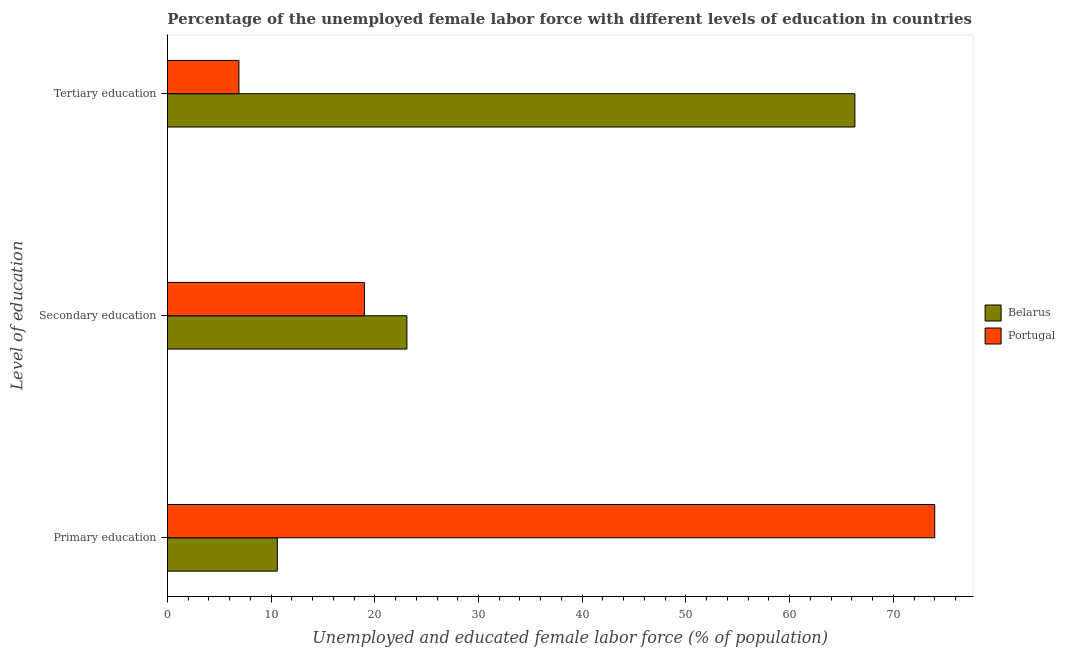How many groups of bars are there?
Offer a very short reply. 3. Are the number of bars per tick equal to the number of legend labels?
Give a very brief answer. Yes. How many bars are there on the 2nd tick from the top?
Provide a short and direct response. 2. How many bars are there on the 1st tick from the bottom?
Provide a short and direct response. 2. What is the label of the 2nd group of bars from the top?
Your response must be concise. Secondary education. What is the percentage of female labor force who received primary education in Belarus?
Your response must be concise. 10.6. Across all countries, what is the maximum percentage of female labor force who received tertiary education?
Offer a very short reply. 66.3. Across all countries, what is the minimum percentage of female labor force who received tertiary education?
Provide a succinct answer. 6.9. In which country was the percentage of female labor force who received tertiary education maximum?
Provide a short and direct response. Belarus. What is the total percentage of female labor force who received tertiary education in the graph?
Give a very brief answer. 73.2. What is the difference between the percentage of female labor force who received primary education in Portugal and that in Belarus?
Your answer should be compact. 63.4. What is the difference between the percentage of female labor force who received secondary education in Portugal and the percentage of female labor force who received tertiary education in Belarus?
Offer a very short reply. -47.3. What is the average percentage of female labor force who received primary education per country?
Your response must be concise. 42.3. What is the difference between the percentage of female labor force who received tertiary education and percentage of female labor force who received secondary education in Belarus?
Provide a short and direct response. 43.2. What is the ratio of the percentage of female labor force who received tertiary education in Portugal to that in Belarus?
Offer a very short reply. 0.1. Is the percentage of female labor force who received tertiary education in Belarus less than that in Portugal?
Give a very brief answer. No. What is the difference between the highest and the second highest percentage of female labor force who received secondary education?
Keep it short and to the point. 4.1. What is the difference between the highest and the lowest percentage of female labor force who received tertiary education?
Keep it short and to the point. 59.4. Is the sum of the percentage of female labor force who received primary education in Portugal and Belarus greater than the maximum percentage of female labor force who received secondary education across all countries?
Offer a terse response. Yes. What does the 2nd bar from the top in Primary education represents?
Your answer should be very brief. Belarus. How many countries are there in the graph?
Your answer should be compact. 2. Does the graph contain any zero values?
Offer a very short reply. No. Does the graph contain grids?
Provide a short and direct response. No. Where does the legend appear in the graph?
Provide a short and direct response. Center right. How are the legend labels stacked?
Your answer should be very brief. Vertical. What is the title of the graph?
Your response must be concise. Percentage of the unemployed female labor force with different levels of education in countries. Does "Turks and Caicos Islands" appear as one of the legend labels in the graph?
Ensure brevity in your answer.  No. What is the label or title of the X-axis?
Offer a very short reply. Unemployed and educated female labor force (% of population). What is the label or title of the Y-axis?
Offer a terse response. Level of education. What is the Unemployed and educated female labor force (% of population) in Belarus in Primary education?
Your answer should be compact. 10.6. What is the Unemployed and educated female labor force (% of population) of Portugal in Primary education?
Your answer should be compact. 74. What is the Unemployed and educated female labor force (% of population) of Belarus in Secondary education?
Provide a short and direct response. 23.1. What is the Unemployed and educated female labor force (% of population) in Portugal in Secondary education?
Make the answer very short. 19. What is the Unemployed and educated female labor force (% of population) of Belarus in Tertiary education?
Offer a very short reply. 66.3. What is the Unemployed and educated female labor force (% of population) in Portugal in Tertiary education?
Offer a terse response. 6.9. Across all Level of education, what is the maximum Unemployed and educated female labor force (% of population) in Belarus?
Ensure brevity in your answer.  66.3. Across all Level of education, what is the maximum Unemployed and educated female labor force (% of population) of Portugal?
Ensure brevity in your answer.  74. Across all Level of education, what is the minimum Unemployed and educated female labor force (% of population) of Belarus?
Your response must be concise. 10.6. Across all Level of education, what is the minimum Unemployed and educated female labor force (% of population) of Portugal?
Provide a succinct answer. 6.9. What is the total Unemployed and educated female labor force (% of population) in Belarus in the graph?
Give a very brief answer. 100. What is the total Unemployed and educated female labor force (% of population) of Portugal in the graph?
Make the answer very short. 99.9. What is the difference between the Unemployed and educated female labor force (% of population) of Belarus in Primary education and that in Tertiary education?
Your response must be concise. -55.7. What is the difference between the Unemployed and educated female labor force (% of population) of Portugal in Primary education and that in Tertiary education?
Ensure brevity in your answer.  67.1. What is the difference between the Unemployed and educated female labor force (% of population) of Belarus in Secondary education and that in Tertiary education?
Your response must be concise. -43.2. What is the difference between the Unemployed and educated female labor force (% of population) in Belarus in Primary education and the Unemployed and educated female labor force (% of population) in Portugal in Tertiary education?
Offer a terse response. 3.7. What is the difference between the Unemployed and educated female labor force (% of population) of Belarus in Secondary education and the Unemployed and educated female labor force (% of population) of Portugal in Tertiary education?
Ensure brevity in your answer.  16.2. What is the average Unemployed and educated female labor force (% of population) in Belarus per Level of education?
Ensure brevity in your answer.  33.33. What is the average Unemployed and educated female labor force (% of population) of Portugal per Level of education?
Keep it short and to the point. 33.3. What is the difference between the Unemployed and educated female labor force (% of population) in Belarus and Unemployed and educated female labor force (% of population) in Portugal in Primary education?
Your answer should be very brief. -63.4. What is the difference between the Unemployed and educated female labor force (% of population) of Belarus and Unemployed and educated female labor force (% of population) of Portugal in Tertiary education?
Give a very brief answer. 59.4. What is the ratio of the Unemployed and educated female labor force (% of population) in Belarus in Primary education to that in Secondary education?
Offer a very short reply. 0.46. What is the ratio of the Unemployed and educated female labor force (% of population) of Portugal in Primary education to that in Secondary education?
Your answer should be very brief. 3.89. What is the ratio of the Unemployed and educated female labor force (% of population) in Belarus in Primary education to that in Tertiary education?
Offer a very short reply. 0.16. What is the ratio of the Unemployed and educated female labor force (% of population) of Portugal in Primary education to that in Tertiary education?
Your response must be concise. 10.72. What is the ratio of the Unemployed and educated female labor force (% of population) in Belarus in Secondary education to that in Tertiary education?
Your response must be concise. 0.35. What is the ratio of the Unemployed and educated female labor force (% of population) in Portugal in Secondary education to that in Tertiary education?
Give a very brief answer. 2.75. What is the difference between the highest and the second highest Unemployed and educated female labor force (% of population) in Belarus?
Keep it short and to the point. 43.2. What is the difference between the highest and the lowest Unemployed and educated female labor force (% of population) in Belarus?
Offer a terse response. 55.7. What is the difference between the highest and the lowest Unemployed and educated female labor force (% of population) in Portugal?
Provide a succinct answer. 67.1. 